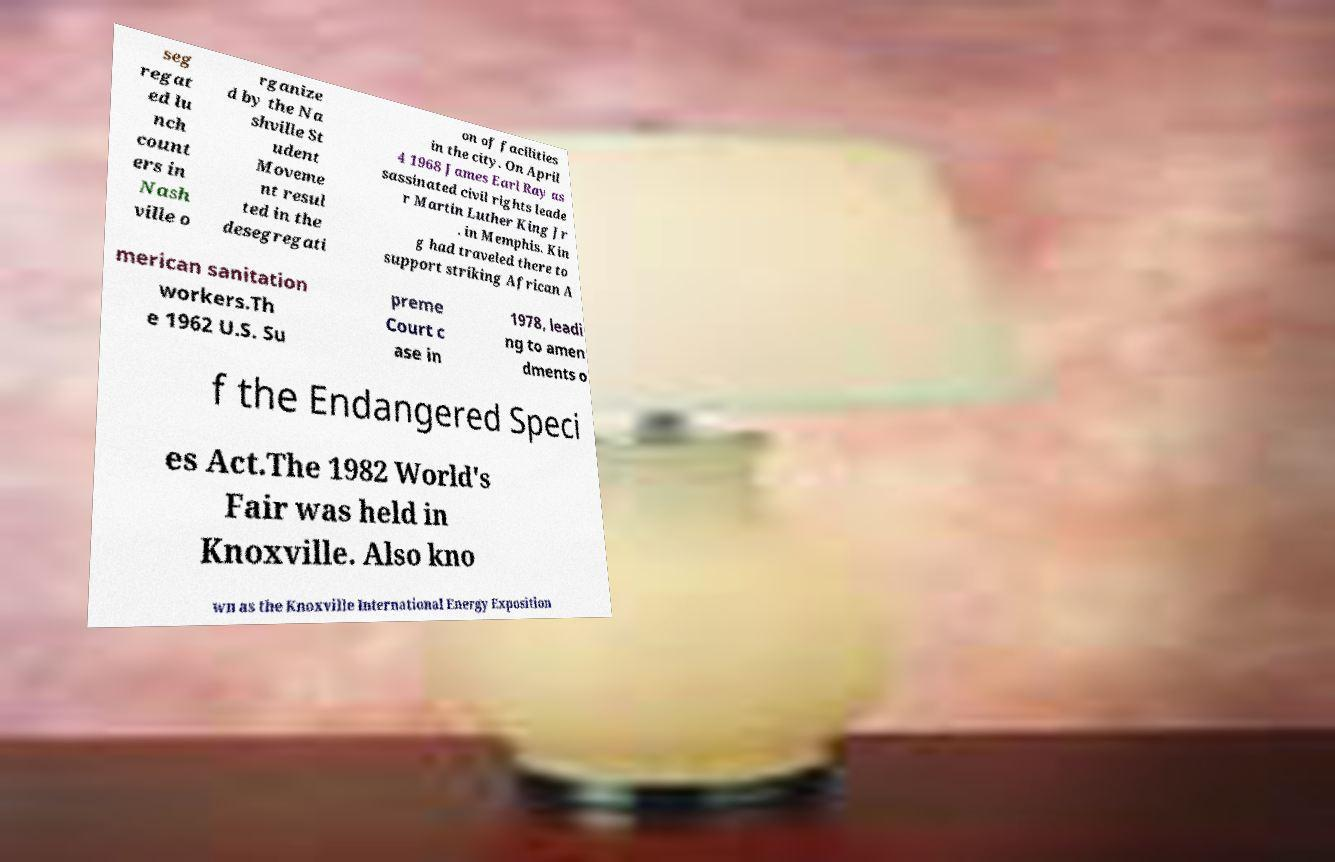Can you read and provide the text displayed in the image?This photo seems to have some interesting text. Can you extract and type it out for me? seg regat ed lu nch count ers in Nash ville o rganize d by the Na shville St udent Moveme nt resul ted in the desegregati on of facilities in the city. On April 4 1968 James Earl Ray as sassinated civil rights leade r Martin Luther King Jr . in Memphis. Kin g had traveled there to support striking African A merican sanitation workers.Th e 1962 U.S. Su preme Court c ase in 1978, leadi ng to amen dments o f the Endangered Speci es Act.The 1982 World's Fair was held in Knoxville. Also kno wn as the Knoxville International Energy Exposition 